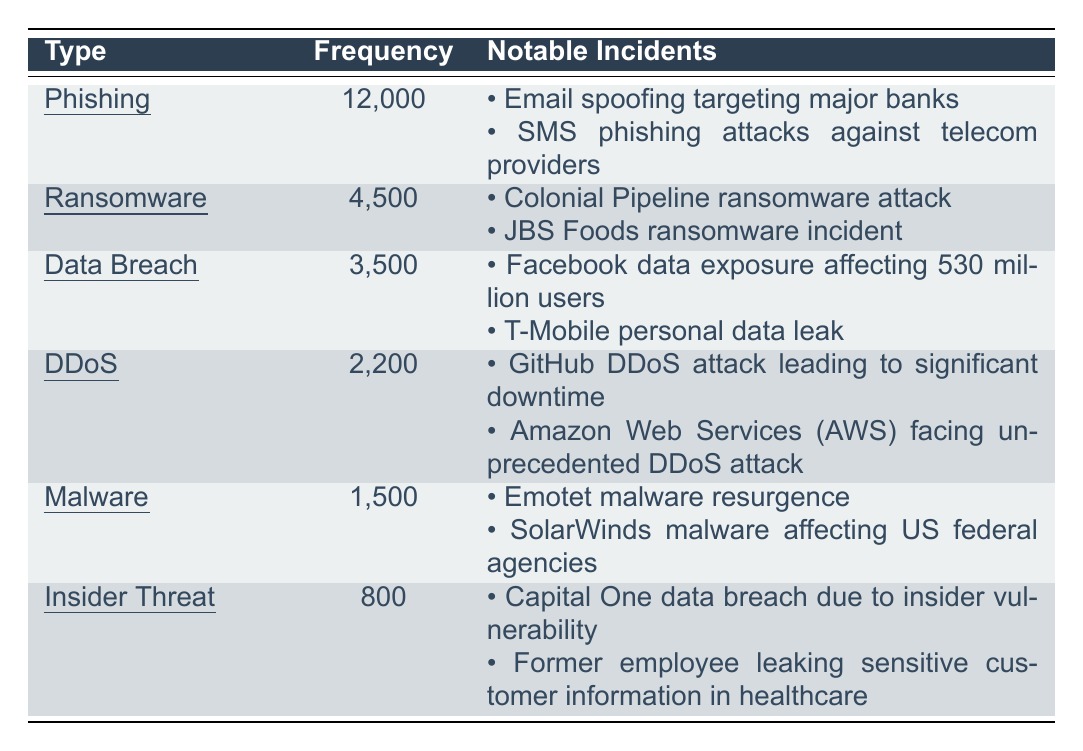What's the frequency of Phishing incidents reported? According to the table, the frequency of Phishing incidents is 12,000.
Answer: 12,000 Which type of cybersecurity incident had the highest frequency in 2022? By comparing the frequencies in the table, Phishing with 12,000 incidents has the highest frequency.
Answer: Phishing How many more Ransomware incidents were reported than Malware incidents? The frequency of Ransomware is 4,500 and Malware is 1,500. The difference is 4,500 - 1,500 = 3,000.
Answer: 3,000 What are the notable incidents reported for Data Breaches? The notable incidents listed for Data Breaches are Facebook data exposure affecting 530 million users and T-Mobile personal data leak.
Answer: Facebook data exposure; T-Mobile leak Is the total frequency of DDoS incidents greater than the total frequency of Insider Threats? The frequency of DDoS is 2,200 and Insider Threats is 800. Since 2,200 is greater than 800, the statement is true.
Answer: Yes What is the total frequency of all incidents combined reported in 2022? To find the total, sum all frequencies: 12,000 + 4,500 + 3,500 + 2,200 + 1,500 + 800 = 24,500.
Answer: 24,500 How many incidents are reported for both Ransomware and DDoS combined? By adding the frequencies: Ransomware (4,500) + DDoS (2,200) = 6,700.
Answer: 6,700 Which incident type reported incidents affecting more than 2,000 cases? By reviewing the frequencies, Phishing (12,000), Ransomware (4,500), and Data Breach (3,500) all exceed 2,000 incidents.
Answer: Phishing, Ransomware, Data Breach If the incidents caused by Insider Threats were eliminated from the total, what would that total be? The total frequency is 24,500. Subtract Insider Threats (800): 24,500 - 800 = 23,700.
Answer: 23,700 Which incident type had the lowest frequency of reports? Comparing all frequencies, Insider Threats reported the lowest with 800 incidents.
Answer: Insider Threat What percentage of the total incidents were classified as Malware? To find the percentage, divide Malware's frequency (1,500) by the total frequency (24,500) and multiply by 100: (1,500 / 24,500) * 100 ≈ 6.12%.
Answer: 6.12% 